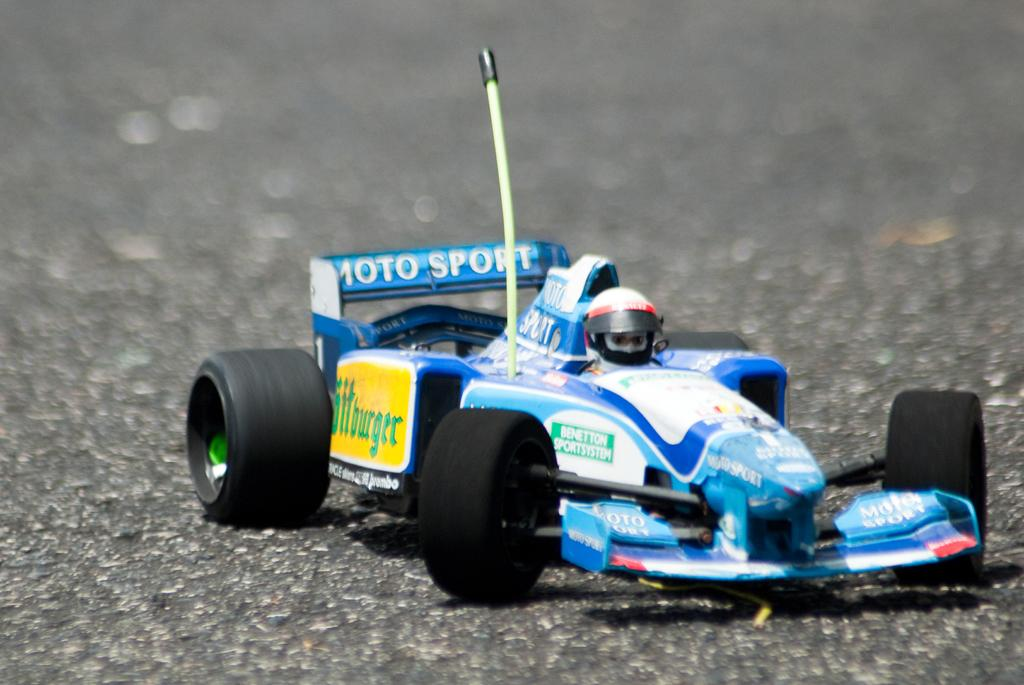What is the main subject of the image? There is a vehicle on the road in the image. Can you describe the person in the image? There is a person on the vehicle. How would you describe the background of the image? The background of the image is blurry. What type of soup is being served in the image? There is no soup present in the image; it features a vehicle on the road with a person on it. 